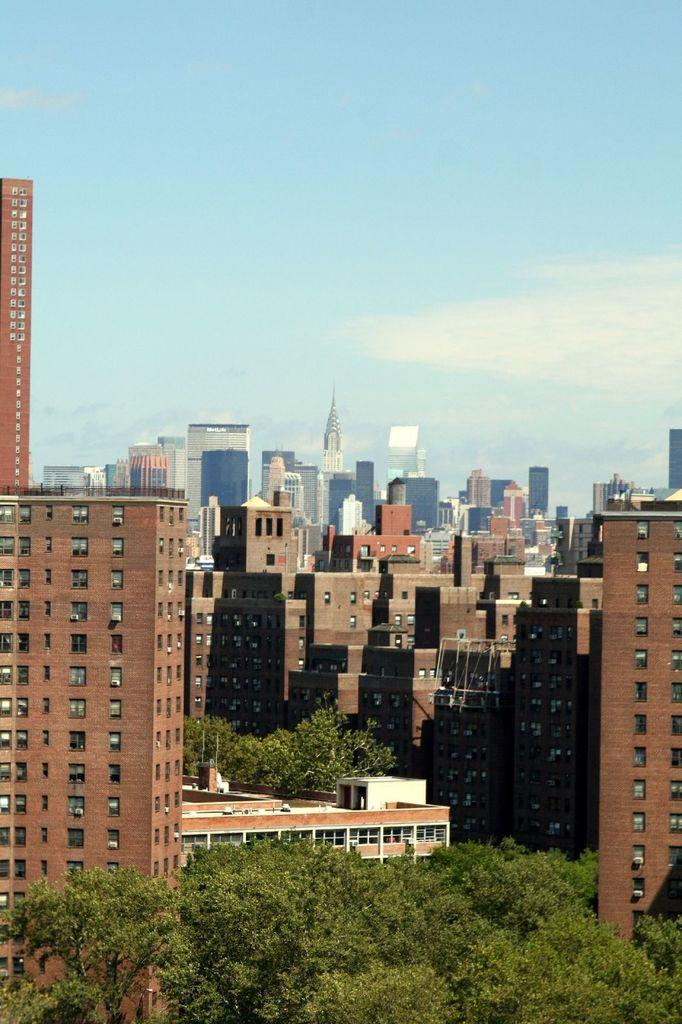What structures can be seen in the image? There are buildings in the image. What type of vegetation is present in front of the buildings? There are trees in front of the buildings. What can be seen in the background of the image? The sky is visible in the background of the image. How many rods are being used to support the trees in the image? There are no rods visible in the image; the trees are not supported by rods. 